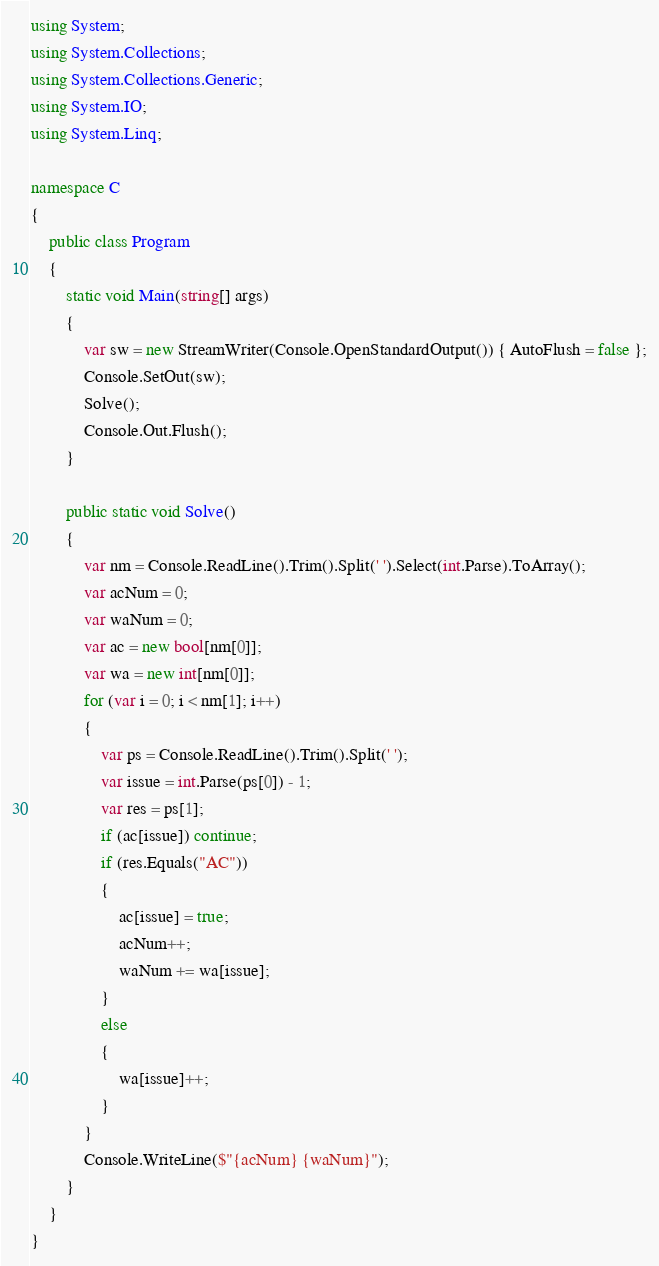Convert code to text. <code><loc_0><loc_0><loc_500><loc_500><_C#_>using System;
using System.Collections;
using System.Collections.Generic;
using System.IO;
using System.Linq;

namespace C
{
    public class Program
    {
        static void Main(string[] args)
        {
            var sw = new StreamWriter(Console.OpenStandardOutput()) { AutoFlush = false };
            Console.SetOut(sw);
            Solve();
            Console.Out.Flush();
        }

        public static void Solve()
        {
            var nm = Console.ReadLine().Trim().Split(' ').Select(int.Parse).ToArray();
            var acNum = 0;
            var waNum = 0;
            var ac = new bool[nm[0]];
            var wa = new int[nm[0]];
            for (var i = 0; i < nm[1]; i++)
            {
                var ps = Console.ReadLine().Trim().Split(' ');
                var issue = int.Parse(ps[0]) - 1;
                var res = ps[1];
                if (ac[issue]) continue;
                if (res.Equals("AC"))
                {
                    ac[issue] = true;
                    acNum++;
                    waNum += wa[issue];
                }
                else
                {
                    wa[issue]++;
                }
            }
            Console.WriteLine($"{acNum} {waNum}");
        }
    }
}
</code> 